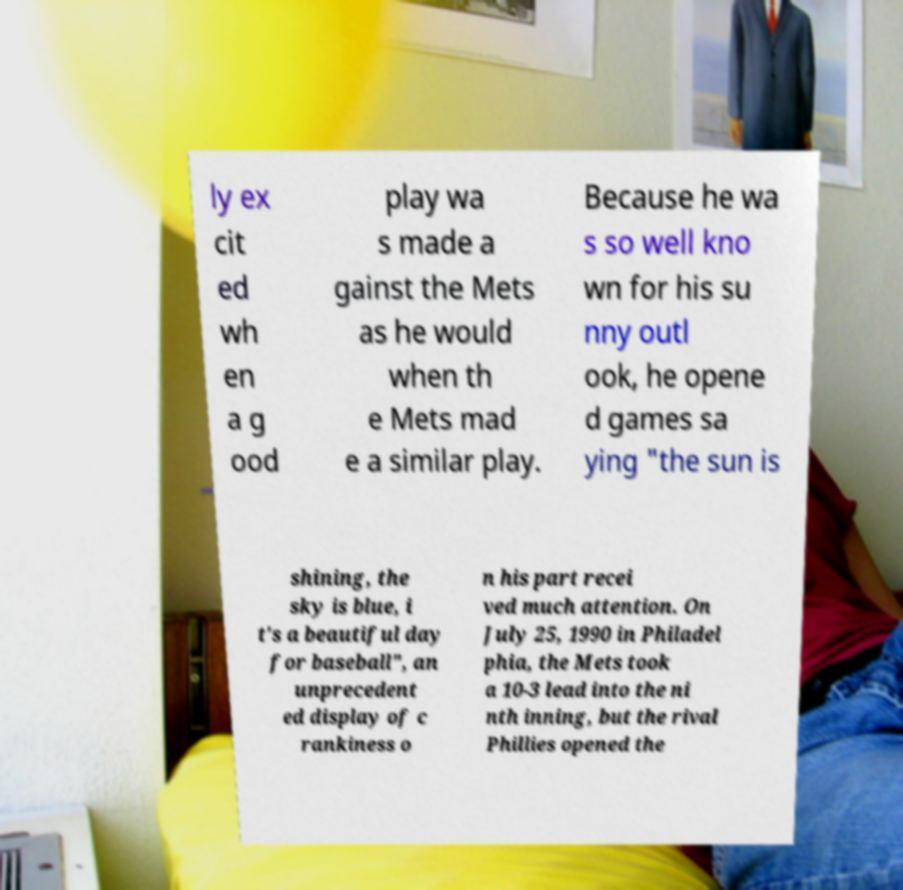There's text embedded in this image that I need extracted. Can you transcribe it verbatim? ly ex cit ed wh en a g ood play wa s made a gainst the Mets as he would when th e Mets mad e a similar play. Because he wa s so well kno wn for his su nny outl ook, he opene d games sa ying "the sun is shining, the sky is blue, i t's a beautiful day for baseball", an unprecedent ed display of c rankiness o n his part recei ved much attention. On July 25, 1990 in Philadel phia, the Mets took a 10-3 lead into the ni nth inning, but the rival Phillies opened the 